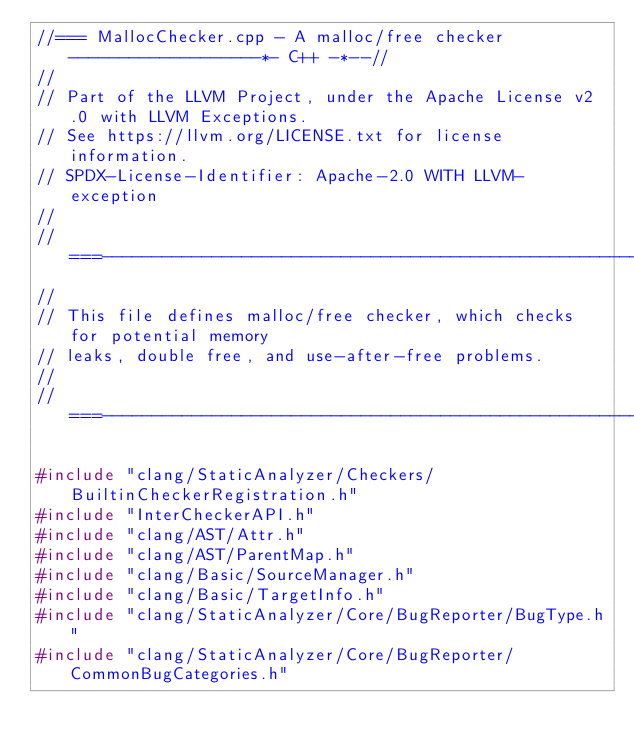<code> <loc_0><loc_0><loc_500><loc_500><_C++_>//=== MallocChecker.cpp - A malloc/free checker -------------------*- C++ -*--//
//
// Part of the LLVM Project, under the Apache License v2.0 with LLVM Exceptions.
// See https://llvm.org/LICENSE.txt for license information.
// SPDX-License-Identifier: Apache-2.0 WITH LLVM-exception
//
//===----------------------------------------------------------------------===//
//
// This file defines malloc/free checker, which checks for potential memory
// leaks, double free, and use-after-free problems.
//
//===----------------------------------------------------------------------===//

#include "clang/StaticAnalyzer/Checkers/BuiltinCheckerRegistration.h"
#include "InterCheckerAPI.h"
#include "clang/AST/Attr.h"
#include "clang/AST/ParentMap.h"
#include "clang/Basic/SourceManager.h"
#include "clang/Basic/TargetInfo.h"
#include "clang/StaticAnalyzer/Core/BugReporter/BugType.h"
#include "clang/StaticAnalyzer/Core/BugReporter/CommonBugCategories.h"</code> 